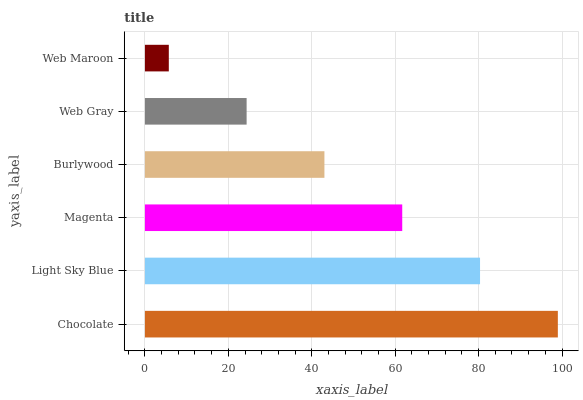Is Web Maroon the minimum?
Answer yes or no. Yes. Is Chocolate the maximum?
Answer yes or no. Yes. Is Light Sky Blue the minimum?
Answer yes or no. No. Is Light Sky Blue the maximum?
Answer yes or no. No. Is Chocolate greater than Light Sky Blue?
Answer yes or no. Yes. Is Light Sky Blue less than Chocolate?
Answer yes or no. Yes. Is Light Sky Blue greater than Chocolate?
Answer yes or no. No. Is Chocolate less than Light Sky Blue?
Answer yes or no. No. Is Magenta the high median?
Answer yes or no. Yes. Is Burlywood the low median?
Answer yes or no. Yes. Is Chocolate the high median?
Answer yes or no. No. Is Web Gray the low median?
Answer yes or no. No. 